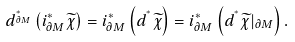Convert formula to latex. <formula><loc_0><loc_0><loc_500><loc_500>d ^ { ^ { * } _ { \partial M } } \left ( i ^ { * } _ { \partial M } \widetilde { \chi } \right ) = i ^ { * } _ { \partial M } \left ( d ^ { ^ { * } } \widetilde { \chi } \right ) = i ^ { * } _ { \partial M } \left ( d ^ { ^ { * } } \widetilde { \chi } | _ { \partial M } \right ) .</formula> 